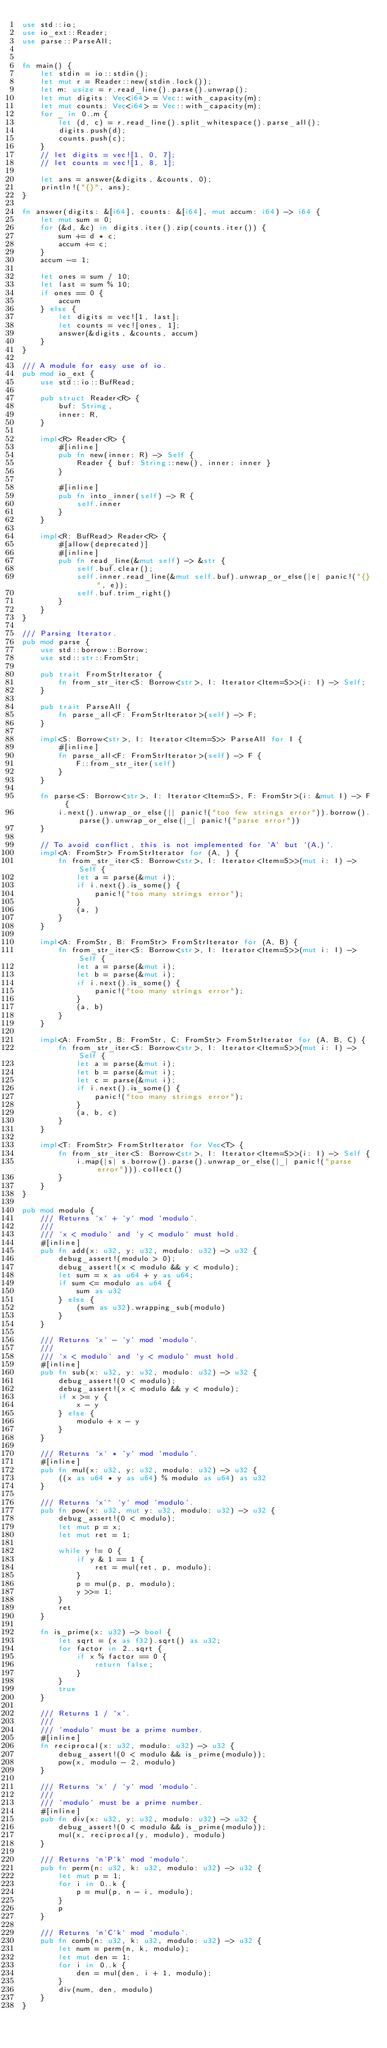<code> <loc_0><loc_0><loc_500><loc_500><_Rust_>use std::io;
use io_ext::Reader;
use parse::ParseAll;


fn main() {
    let stdin = io::stdin();
    let mut r = Reader::new(stdin.lock());
    let m: usize = r.read_line().parse().unwrap();
    let mut digits: Vec<i64> = Vec::with_capacity(m);
    let mut counts: Vec<i64> = Vec::with_capacity(m);
    for _ in 0..m {
        let (d, c) = r.read_line().split_whitespace().parse_all();
        digits.push(d);
        counts.push(c);
    }
    // let digits = vec![1, 0, 7];
    // let counts = vec![1, 8, 1];

    let ans = answer(&digits, &counts, 0);
    println!("{}", ans);
}

fn answer(digits: &[i64], counts: &[i64], mut accum: i64) -> i64 {
    let mut sum = 0;
    for (&d, &c) in digits.iter().zip(counts.iter()) {
        sum += d * c;
        accum += c;
    }
    accum -= 1;

    let ones = sum / 10;
    let last = sum % 10;
    if ones == 0 {
        accum
    } else {
        let digits = vec![1, last];
        let counts = vec![ones, 1];
        answer(&digits, &counts, accum)
    }
}

/// A module for easy use of io.
pub mod io_ext {
    use std::io::BufRead;

    pub struct Reader<R> {
        buf: String,
        inner: R,
    }

    impl<R> Reader<R> {
        #[inline]
        pub fn new(inner: R) -> Self {
            Reader { buf: String::new(), inner: inner }
        }

        #[inline]
        pub fn into_inner(self) -> R {
            self.inner
        }
    }

    impl<R: BufRead> Reader<R> {
        #[allow(deprecated)]
        #[inline]
        pub fn read_line(&mut self) -> &str {
            self.buf.clear();
            self.inner.read_line(&mut self.buf).unwrap_or_else(|e| panic!("{}", e));
            self.buf.trim_right()
        }
    }
}

/// Parsing Iterator.
pub mod parse {
    use std::borrow::Borrow;
    use std::str::FromStr;

    pub trait FromStrIterator {
        fn from_str_iter<S: Borrow<str>, I: Iterator<Item=S>>(i: I) -> Self;
    }

    pub trait ParseAll {
        fn parse_all<F: FromStrIterator>(self) -> F;
    }

    impl<S: Borrow<str>, I: Iterator<Item=S>> ParseAll for I {
        #[inline]
        fn parse_all<F: FromStrIterator>(self) -> F {
            F::from_str_iter(self)
        }
    }

    fn parse<S: Borrow<str>, I: Iterator<Item=S>, F: FromStr>(i: &mut I) -> F {
        i.next().unwrap_or_else(|| panic!("too few strings error")).borrow().parse().unwrap_or_else(|_| panic!("parse error"))
    }

    // To avoid conflict, this is not implemented for `A` but `(A,)`.
    impl<A: FromStr> FromStrIterator for (A, ) {
        fn from_str_iter<S: Borrow<str>, I: Iterator<Item=S>>(mut i: I) -> Self {
            let a = parse(&mut i);
            if i.next().is_some() {
                panic!("too many strings error");
            }
            (a, )
        }
    }

    impl<A: FromStr, B: FromStr> FromStrIterator for (A, B) {
        fn from_str_iter<S: Borrow<str>, I: Iterator<Item=S>>(mut i: I) -> Self {
            let a = parse(&mut i);
            let b = parse(&mut i);
            if i.next().is_some() {
                panic!("too many strings error");
            }
            (a, b)
        }
    }

    impl<A: FromStr, B: FromStr, C: FromStr> FromStrIterator for (A, B, C) {
        fn from_str_iter<S: Borrow<str>, I: Iterator<Item=S>>(mut i: I) -> Self {
            let a = parse(&mut i);
            let b = parse(&mut i);
            let c = parse(&mut i);
            if i.next().is_some() {
                panic!("too many strings error");
            }
            (a, b, c)
        }
    }

    impl<T: FromStr> FromStrIterator for Vec<T> {
        fn from_str_iter<S: Borrow<str>, I: Iterator<Item=S>>(i: I) -> Self {
            i.map(|s| s.borrow().parse().unwrap_or_else(|_| panic!("parse error"))).collect()
        }
    }
}

pub mod modulo {
    /// Returns `x` + `y` mod `modulo`.
    ///
    /// `x < modulo` and `y < modulo` must hold.
    #[inline]
    pub fn add(x: u32, y: u32, modulo: u32) -> u32 {
        debug_assert!(modulo > 0);
        debug_assert!(x < modulo && y < modulo);
        let sum = x as u64 + y as u64;
        if sum <= modulo as u64 {
            sum as u32
        } else {
            (sum as u32).wrapping_sub(modulo)
        }
    }

    /// Returns `x` - `y` mod `modulo`.
    ///
    /// `x < modulo` and `y < modulo` must hold.
    #[inline]
    pub fn sub(x: u32, y: u32, modulo: u32) -> u32 {
        debug_assert!(0 < modulo);
        debug_assert!(x < modulo && y < modulo);
        if x >= y {
            x - y
        } else {
            modulo + x - y
        }
    }

    /// Returns `x` * `y` mod `modulo`.
    #[inline]
    pub fn mul(x: u32, y: u32, modulo: u32) -> u32 {
        ((x as u64 * y as u64) % modulo as u64) as u32
    }

    /// Returns `x`^ `y` mod `modulo`.
    pub fn pow(x: u32, mut y: u32, modulo: u32) -> u32 {
        debug_assert!(0 < modulo);
        let mut p = x;
        let mut ret = 1;

        while y != 0 {
            if y & 1 == 1 {
                ret = mul(ret, p, modulo);
            }
            p = mul(p, p, modulo);
            y >>= 1;
        }
        ret
    }

    fn is_prime(x: u32) -> bool {
        let sqrt = (x as f32).sqrt() as u32;
        for factor in 2..sqrt {
            if x % factor == 0 {
                return false;
            }
        }
        true
    }

    /// Returns 1 / `x`.
    ///
    /// `modulo` must be a prime number.
    #[inline]
    fn reciprocal(x: u32, modulo: u32) -> u32 {
        debug_assert!(0 < modulo && is_prime(modulo));
        pow(x, modulo - 2, modulo)
    }

    /// Returns `x` / `y` mod `modulo`.
    ///
    /// `modulo` must be a prime number.
    #[inline]
    pub fn div(x: u32, y: u32, modulo: u32) -> u32 {
        debug_assert!(0 < modulo && is_prime(modulo));
        mul(x, reciprocal(y, modulo), modulo)
    }

    /// Returns `n`P`k` mod `modulo`.
    pub fn perm(n: u32, k: u32, modulo: u32) -> u32 {
        let mut p = 1;
        for i in 0..k {
            p = mul(p, n - i, modulo);
        }
        p
    }

    /// Returns `n`C`k` mod `modulo`.
    pub fn comb(n: u32, k: u32, modulo: u32) -> u32 {
        let num = perm(n, k, modulo);
        let mut den = 1;
        for i in 0..k {
            den = mul(den, i + 1, modulo);
        }
        div(num, den, modulo)
    }
}
</code> 